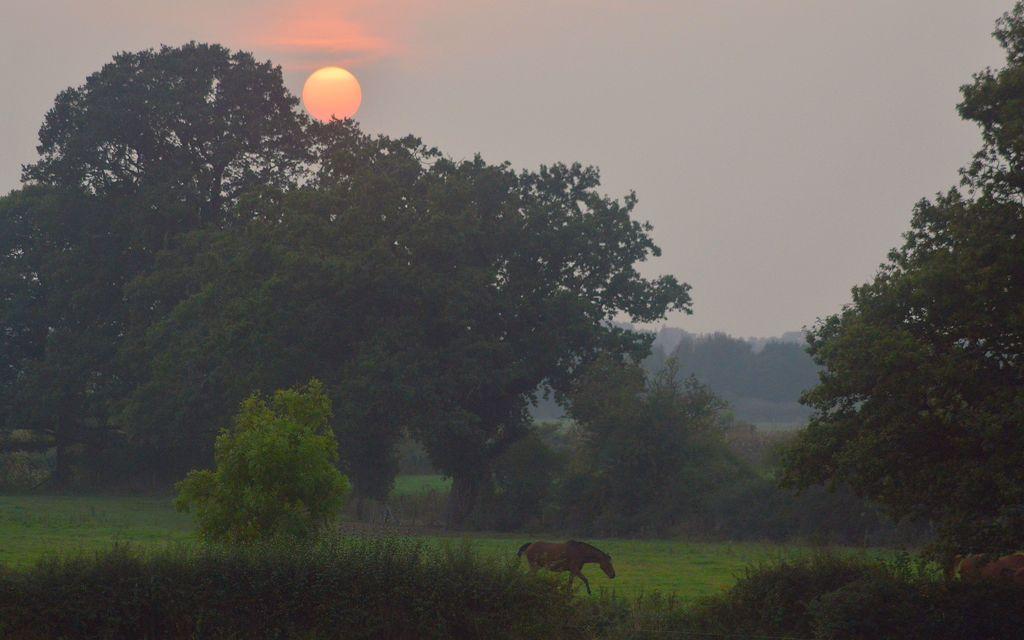How would you summarize this image in a sentence or two? This image is taken during the sunrise. At the bottom there are small plants and grass. In the background there are trees. At the top there is the sky. There is the horse walking on the ground. 